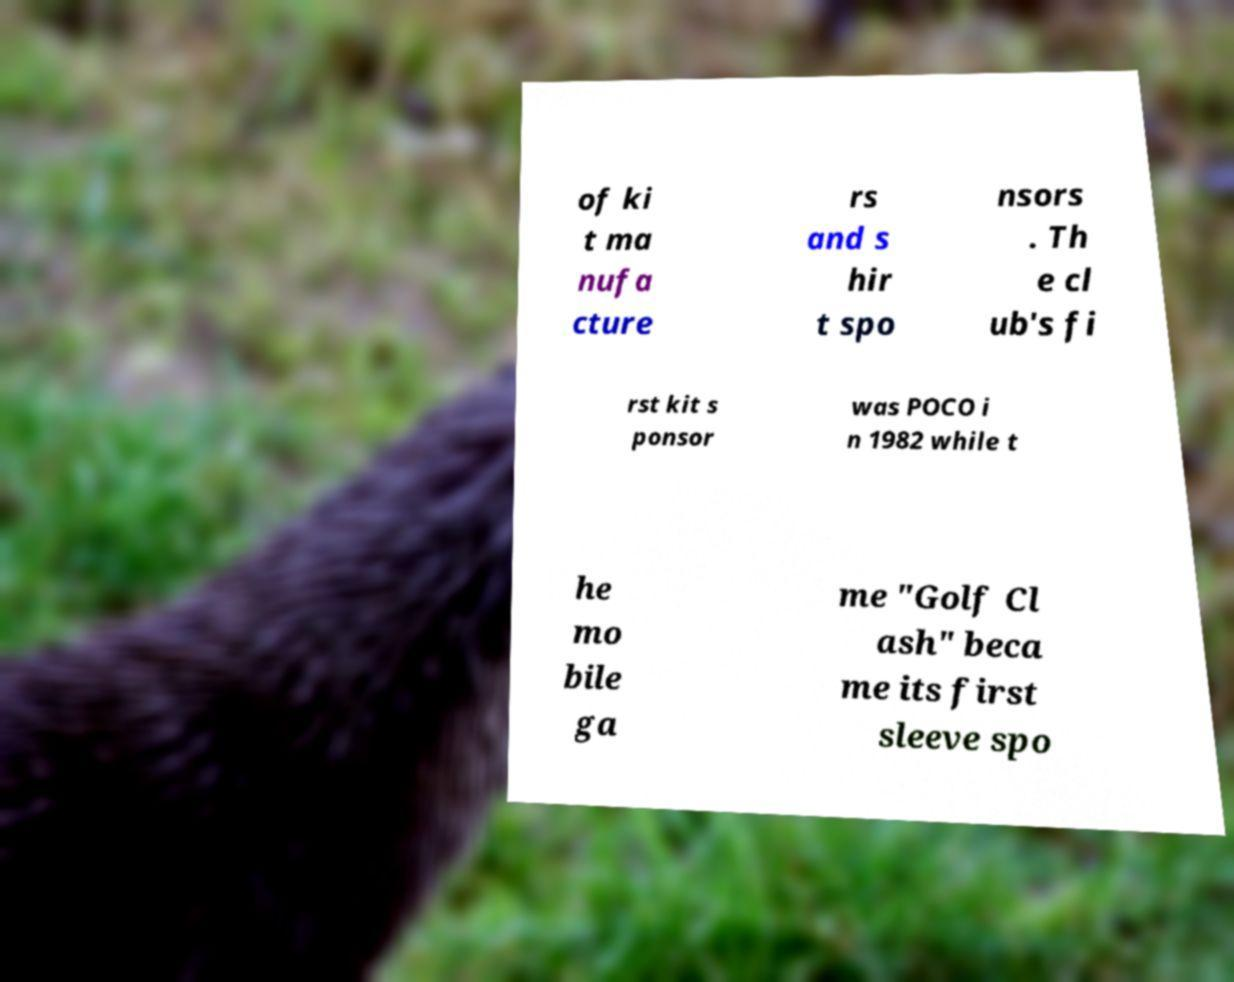Could you extract and type out the text from this image? of ki t ma nufa cture rs and s hir t spo nsors . Th e cl ub's fi rst kit s ponsor was POCO i n 1982 while t he mo bile ga me "Golf Cl ash" beca me its first sleeve spo 